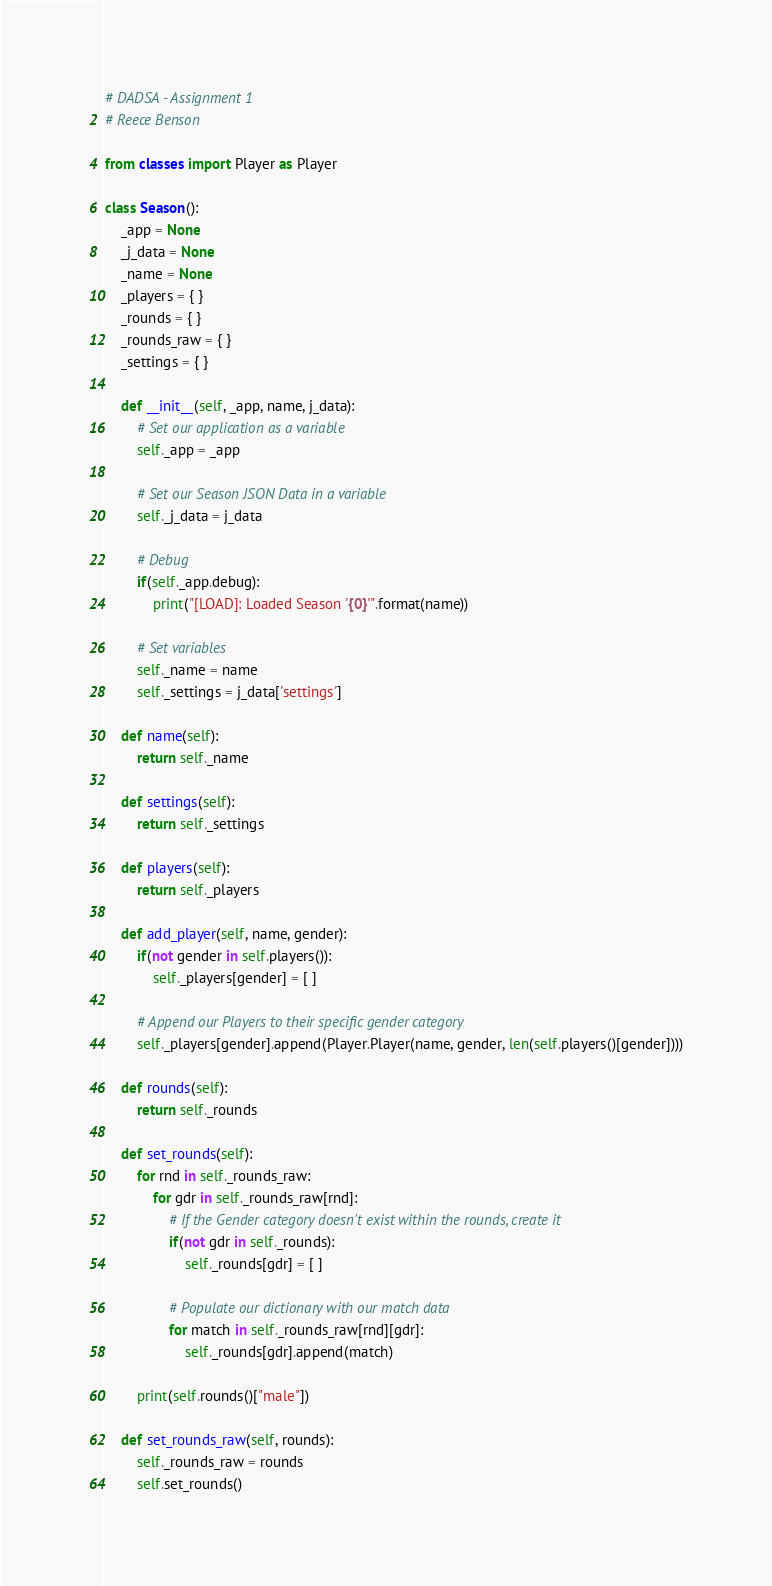<code> <loc_0><loc_0><loc_500><loc_500><_Python_># DADSA - Assignment 1
# Reece Benson

from classes import Player as Player

class Season():
    _app = None
    _j_data = None
    _name = None
    _players = { }
    _rounds = { }
    _rounds_raw = { }
    _settings = { }

    def __init__(self, _app, name, j_data):
        # Set our application as a variable
        self._app = _app
        
        # Set our Season JSON Data in a variable
        self._j_data = j_data

        # Debug
        if(self._app.debug):
            print("[LOAD]: Loaded Season '{0}'".format(name))

        # Set variables
        self._name = name
        self._settings = j_data['settings']

    def name(self):
        return self._name

    def settings(self):
        return self._settings

    def players(self):
        return self._players

    def add_player(self, name, gender):
        if(not gender in self.players()):
            self._players[gender] = [ ]

        # Append our Players to their specific gender category
        self._players[gender].append(Player.Player(name, gender, len(self.players()[gender])))

    def rounds(self):
        return self._rounds

    def set_rounds(self):
        for rnd in self._rounds_raw:
            for gdr in self._rounds_raw[rnd]:
                # If the Gender category doesn't exist within the rounds, create it
                if(not gdr in self._rounds):
                    self._rounds[gdr] = [ ]

                # Populate our dictionary with our match data
                for match in self._rounds_raw[rnd][gdr]:
                    self._rounds[gdr].append(match)

        print(self.rounds()["male"])

    def set_rounds_raw(self, rounds):
        self._rounds_raw = rounds
        self.set_rounds()
</code> 